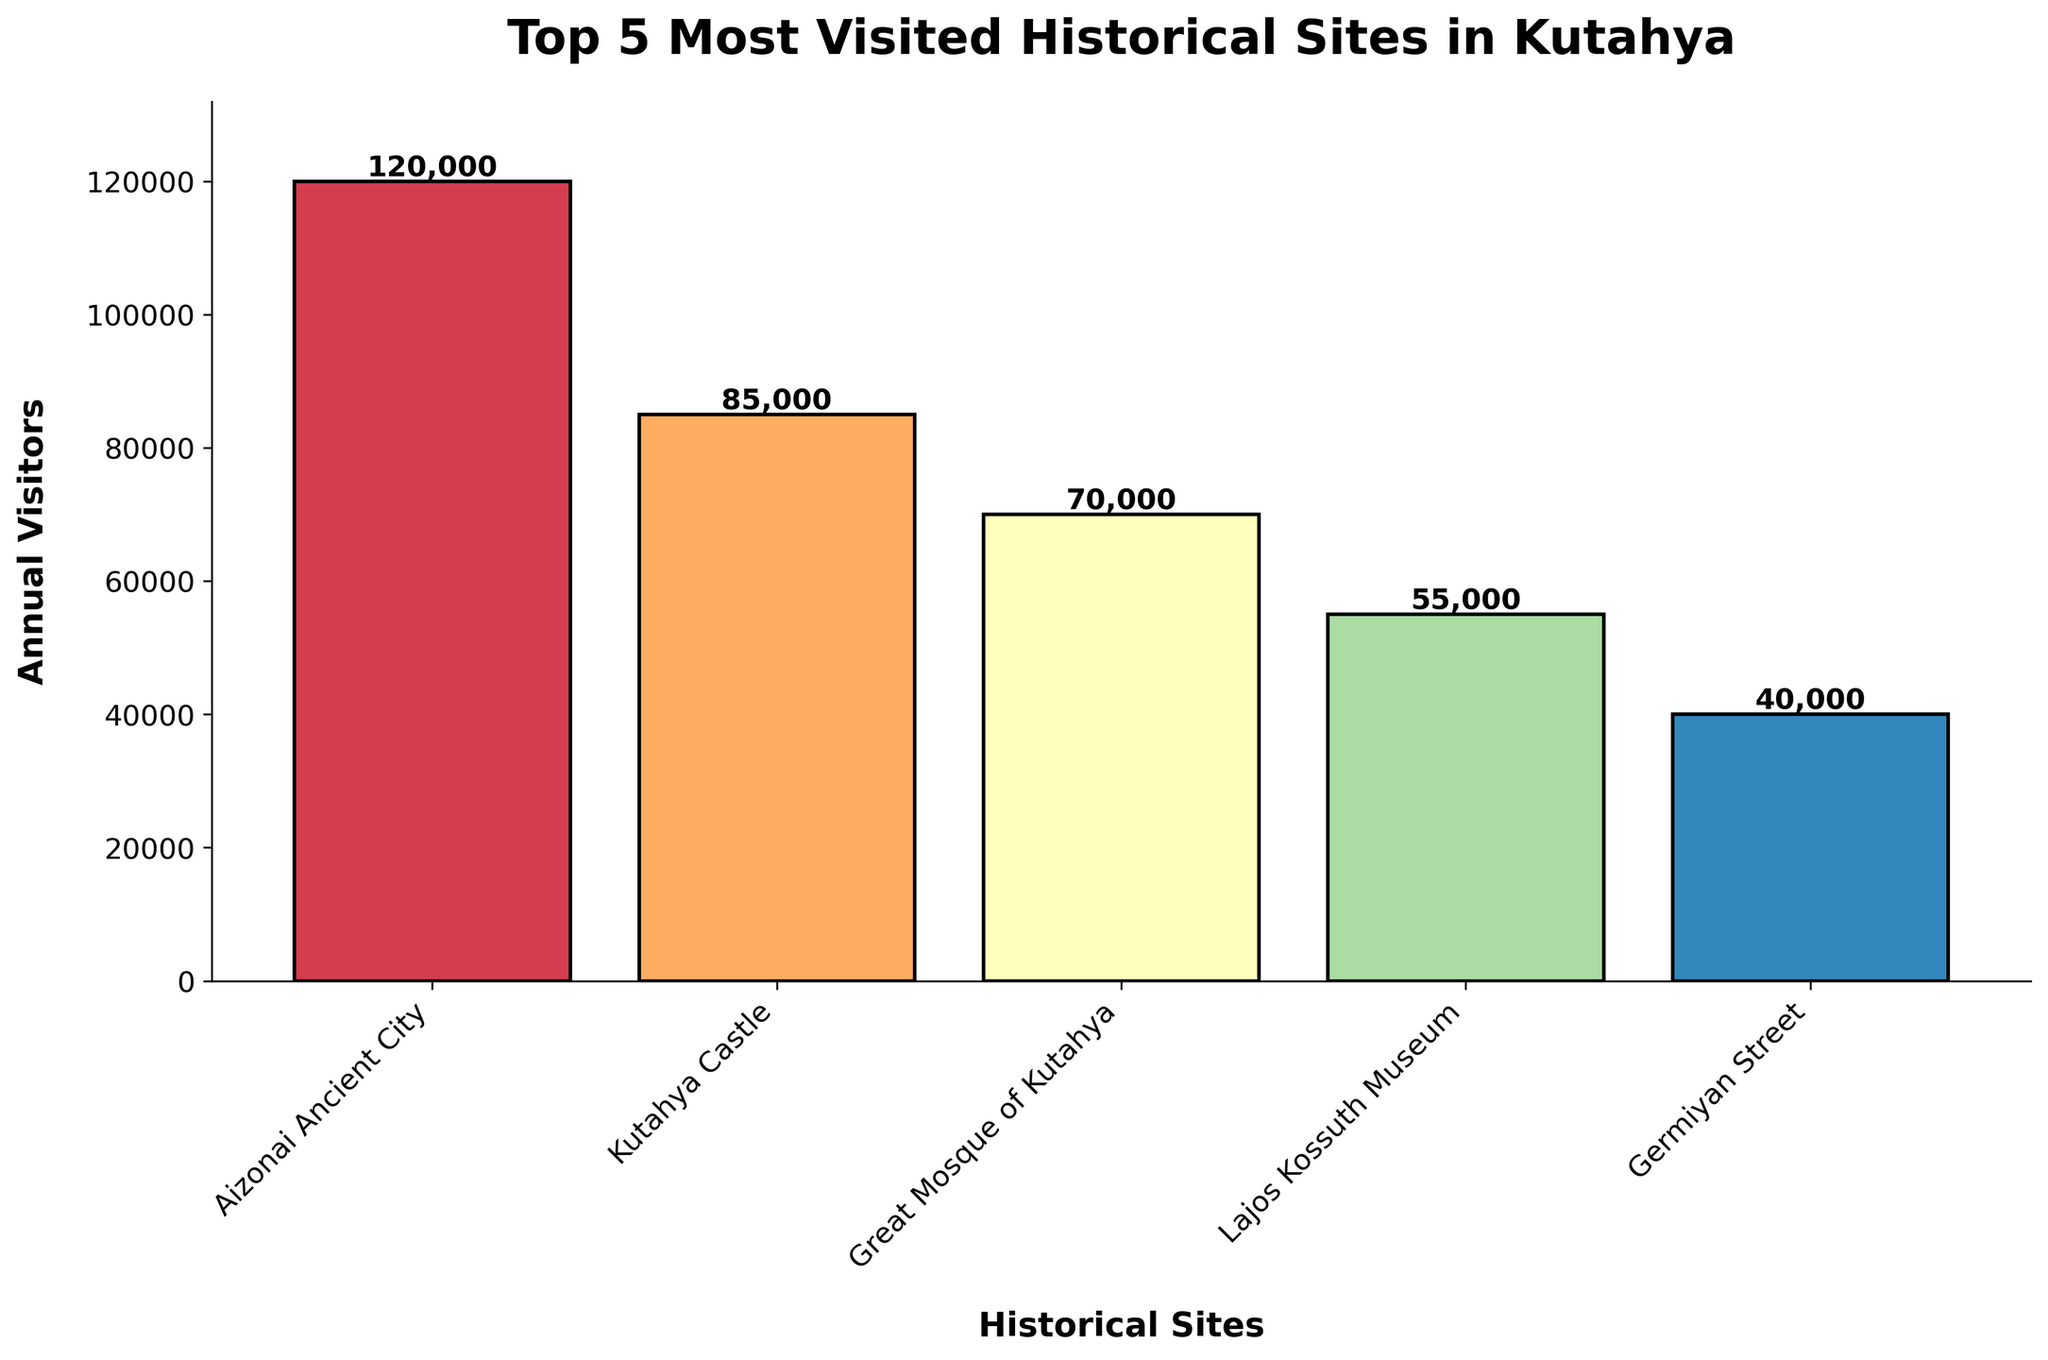Which historical site has the highest number of annual visitors? The site with the highest bar represents the most visited historical site. According to the chart, Aizonai Ancient City has the highest bar, indicating it has the most annual visitors.
Answer: Aizonai Ancient City How many more visitors does Kutahya Castle have compared to Germiyan Street? Find the visitor numbers for Kutahya Castle (85,000) and Germiyan Street (40,000). Subtract Germiyan Street’s visitors from Kutahya Castle’s visitors: 85,000 - 40,000 = 45,000.
Answer: 45,000 What is the total number of annual visitors for all five historical sites combined? Sum the visitor numbers for all sites: 120,000 (Aizonai Ancient City) + 85,000 (Kutahya Castle) + 70,000 (Great Mosque of Kutahya) + 55,000 (Lajos Kossuth Museum) + 40,000 (Germiyan Street) = 370,000.
Answer: 370,000 Which historical site has the second least number of annual visitors and how many visitors does it have? Ordered from least to most visitors: Germiyan Street (40,000), Lajos Kossuth Museum (55,000). Hence, Lajos Kossuth Museum has the second least number of visitors.
Answer: Lajos Kossuth Museum, 55,000 How many visitors does the Great Mosque of Kutahya receive compared to Lajos Kossuth Museum? The Great Mosque of Kutahya has 70,000 visitors, while the Lajos Kossuth Museum has 55,000 visitors. Subtract the visitors of Lajos Kossuth Museum from those of the Great Mosque of Kutahya: 70,000 - 55,000 = 15,000.
Answer: 15,000 Which two sites have a combined visitor count equal to more than half of the total visitors for all sites? Total visitors for all sites are 370,000. Half of this is 185,000. Aizonai Ancient City (120,000) and Kutahya Castle (85,000) combined exceed this with: 120,000 + 85,000 = 205,000.
Answer: Aizonai Ancient City and Kutahya Castle What is the average number of annual visitors across the five historical sites? Sum the visitor numbers for all sites (370,000) and divide by 5 (the number of sites): 370,000 / 5 = 74,000.
Answer: 74,000 